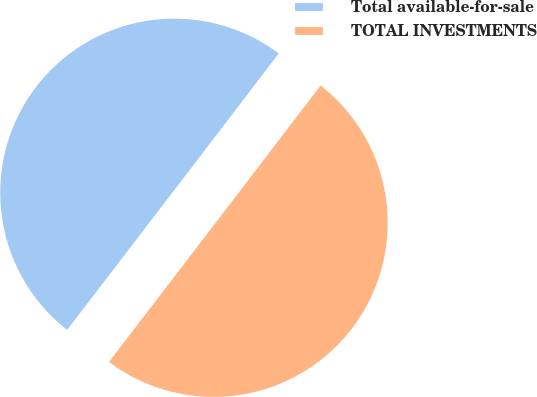Convert chart. <chart><loc_0><loc_0><loc_500><loc_500><pie_chart><fcel>Total available-for-sale<fcel>TOTAL INVESTMENTS<nl><fcel>49.98%<fcel>50.02%<nl></chart> 